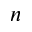Convert formula to latex. <formula><loc_0><loc_0><loc_500><loc_500>n</formula> 